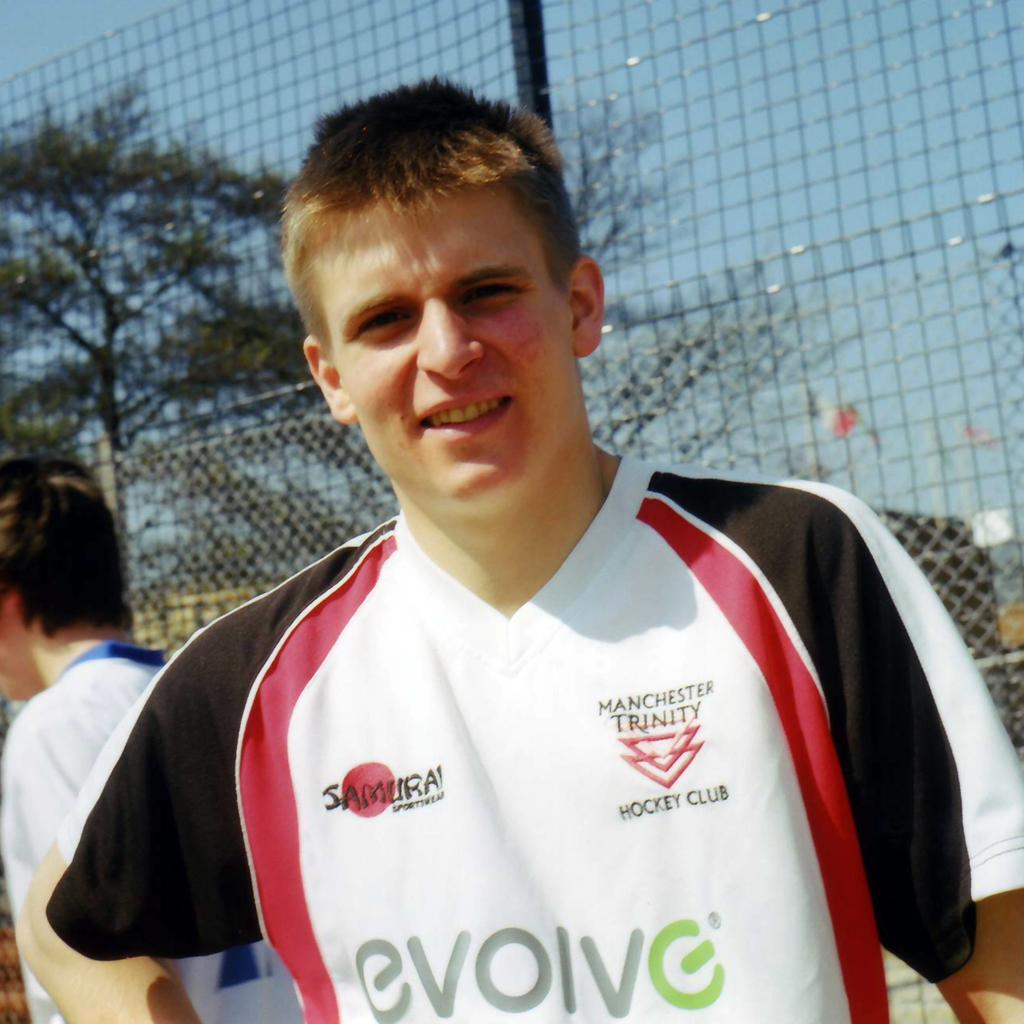<image>
Render a clear and concise summary of the photo. Young man with a jersey that have evolve on it with gray and green letters. 